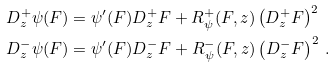<formula> <loc_0><loc_0><loc_500><loc_500>D _ { z } ^ { + } \psi ( F ) & = \psi ^ { \prime } ( F ) D _ { z } ^ { + } F + R _ { \psi } ^ { + } ( F , z ) \left ( D ^ { + } _ { z } F \right ) ^ { 2 } \quad \\ D _ { z } ^ { - } \psi ( F ) & = \psi ^ { \prime } ( F ) D _ { z } ^ { - } F + R _ { \psi } ^ { - } ( F , z ) \left ( D ^ { - } _ { z } F \right ) ^ { 2 } \, .</formula> 